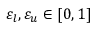<formula> <loc_0><loc_0><loc_500><loc_500>\varepsilon _ { l } , \varepsilon _ { u } \in [ 0 , 1 ]</formula> 